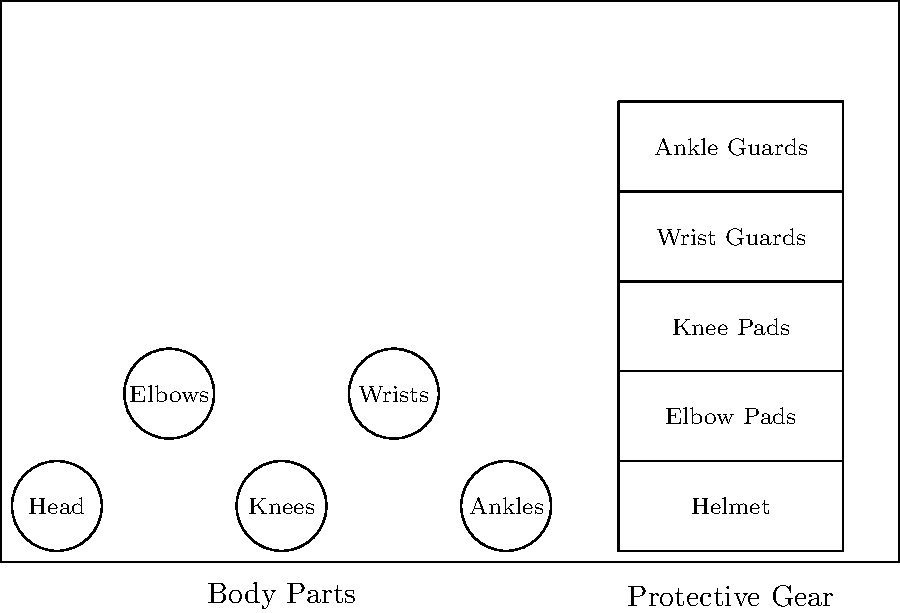Match the skateboarding protective gear to the corresponding body parts. Which gear is specifically designed to protect against wrist injuries during falls? To answer this question, let's analyze the protective gear and their corresponding body parts:

1. Helmet: Designed to protect the head from impacts during falls.
2. Elbow Pads: Used to protect the elbows from scrapes and impacts.
3. Knee Pads: Protect the knees from injuries during falls and slides.
4. Wrist Guards: Specifically designed to protect the wrists from injuries during falls.
5. Ankle Guards: Provide support and protection for the ankles.

When skateboarding, falls are common, and skaters often instinctively use their hands to break their fall. This can lead to wrist injuries if not properly protected. Wrist guards are specifically designed to address this issue by:

1. Providing a rigid surface to slide on during falls, reducing the impact on the wrist.
2. Limiting wrist hyperextension, which can cause sprains or fractures.
3. Offering padding to absorb shock and protect against abrasions.

Therefore, the gear specifically designed to protect against wrist injuries during falls is the wrist guards.
Answer: Wrist Guards 